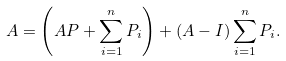<formula> <loc_0><loc_0><loc_500><loc_500>A = \left ( A P + \sum _ { i = 1 } ^ { n } P _ { i } \right ) + ( A - I ) \sum _ { i = 1 } ^ { n } P _ { i } .</formula> 